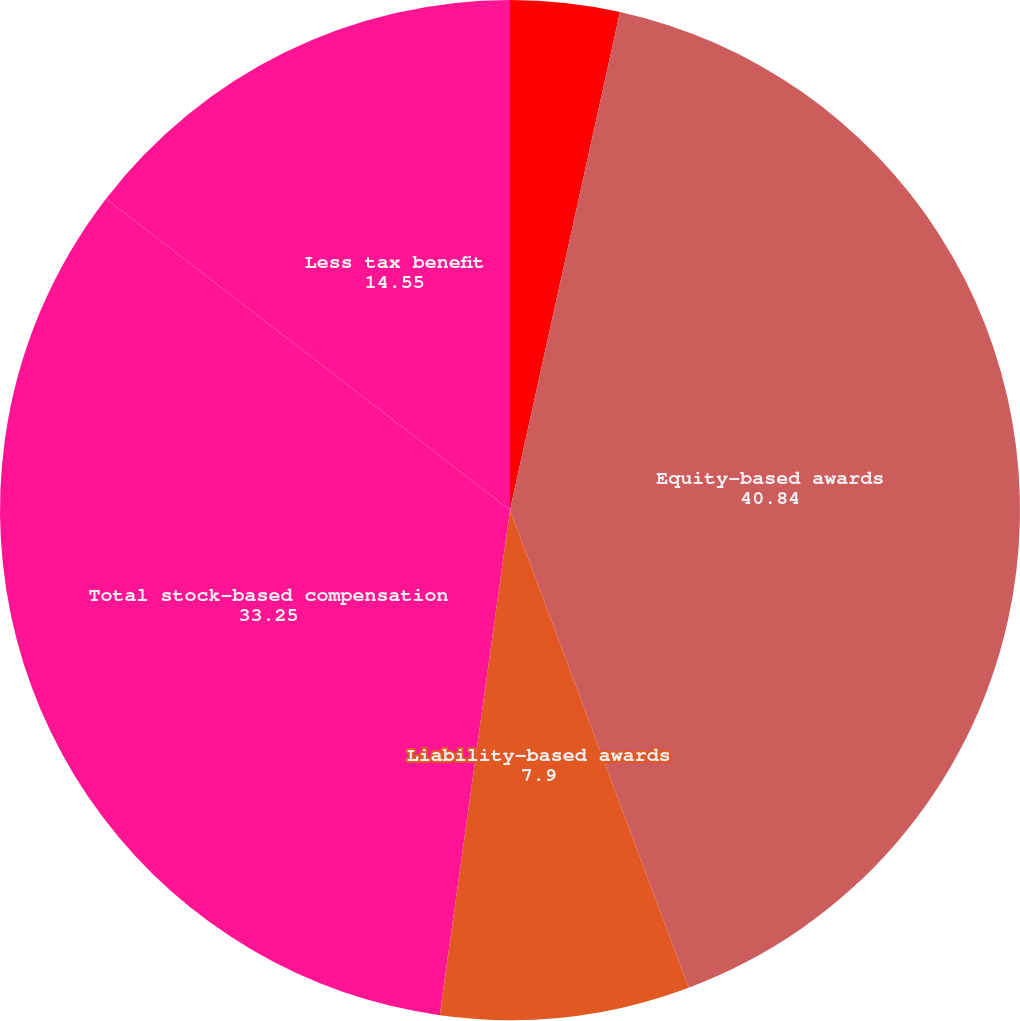Convert chart to OTSL. <chart><loc_0><loc_0><loc_500><loc_500><pie_chart><fcel>(DOLLARS IN THOUSANDS)<fcel>Equity-based awards<fcel>Liability-based awards<fcel>Total stock-based compensation<fcel>Less tax benefit<nl><fcel>3.46%<fcel>40.84%<fcel>7.9%<fcel>33.25%<fcel>14.55%<nl></chart> 